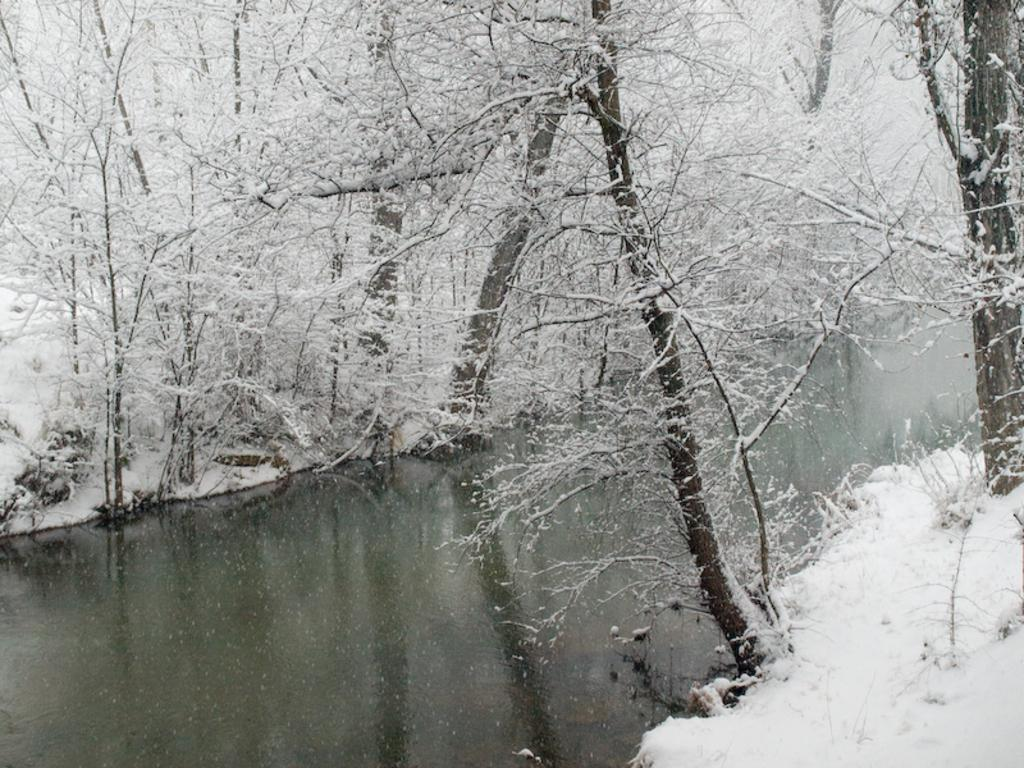What is the primary element visible in the image? There is water in the image. What type of vegetation can be seen in the image? There are trees in the image. What weather condition is depicted in the image? There is snow in the image. Can you see a robin reading a notebook in the image? There is no robin or notebook present in the image. 